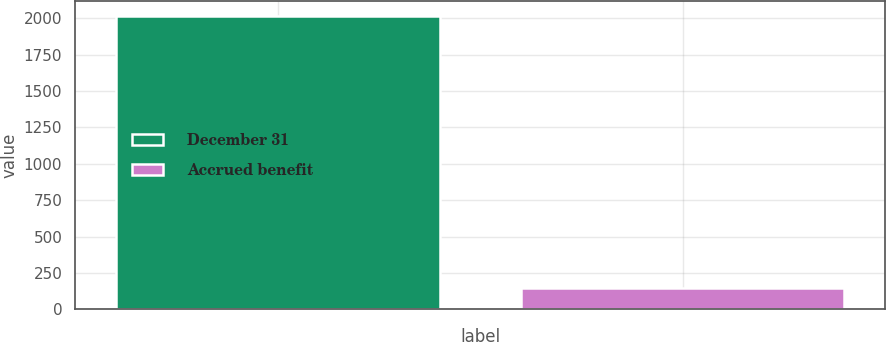<chart> <loc_0><loc_0><loc_500><loc_500><bar_chart><fcel>December 31<fcel>Accrued benefit<nl><fcel>2016<fcel>144<nl></chart> 